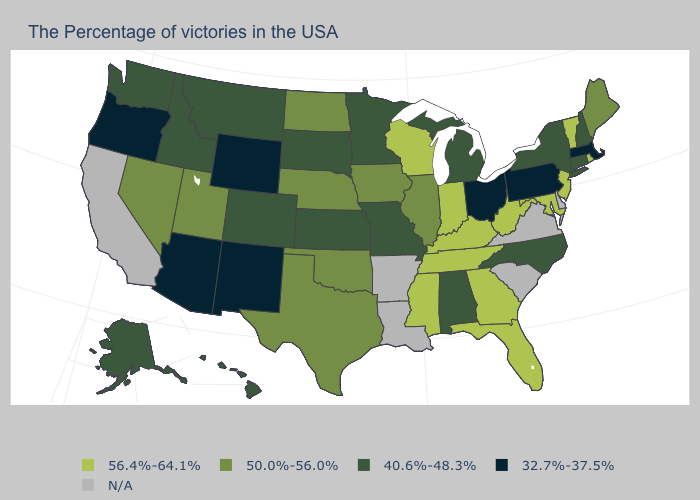Among the states that border West Virginia , does Kentucky have the lowest value?
Quick response, please. No. Which states have the highest value in the USA?
Quick response, please. Rhode Island, Vermont, New Jersey, Maryland, West Virginia, Florida, Georgia, Kentucky, Indiana, Tennessee, Wisconsin, Mississippi. What is the value of North Dakota?
Keep it brief. 50.0%-56.0%. What is the highest value in states that border New Mexico?
Give a very brief answer. 50.0%-56.0%. Name the states that have a value in the range 50.0%-56.0%?
Answer briefly. Maine, Illinois, Iowa, Nebraska, Oklahoma, Texas, North Dakota, Utah, Nevada. What is the value of New Hampshire?
Quick response, please. 40.6%-48.3%. Which states hav the highest value in the West?
Write a very short answer. Utah, Nevada. What is the highest value in the MidWest ?
Short answer required. 56.4%-64.1%. Which states hav the highest value in the Northeast?
Keep it brief. Rhode Island, Vermont, New Jersey. Name the states that have a value in the range N/A?
Give a very brief answer. Delaware, Virginia, South Carolina, Louisiana, Arkansas, California. What is the value of New Mexico?
Keep it brief. 32.7%-37.5%. Does Mississippi have the lowest value in the South?
Answer briefly. No. What is the value of South Carolina?
Quick response, please. N/A. Name the states that have a value in the range 50.0%-56.0%?
Concise answer only. Maine, Illinois, Iowa, Nebraska, Oklahoma, Texas, North Dakota, Utah, Nevada. 